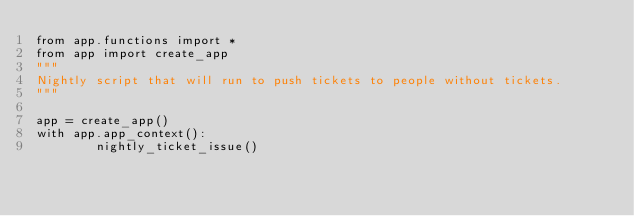Convert code to text. <code><loc_0><loc_0><loc_500><loc_500><_Python_>from app.functions import *
from app import create_app
"""
Nightly script that will run to push tickets to people without tickets.
"""

app = create_app()
with app.app_context():
        nightly_ticket_issue()
</code> 